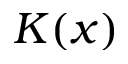<formula> <loc_0><loc_0><loc_500><loc_500>K ( x )</formula> 